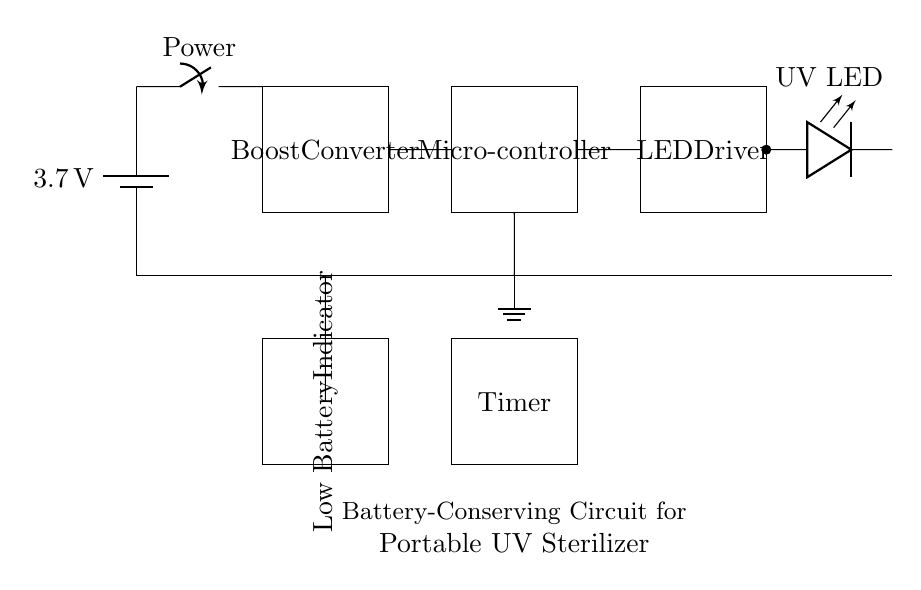What is the voltage rating of the battery? The voltage rating of the battery is indicated on the battery symbol, which shows a value of 3.7 volts.
Answer: 3.7 volts What component is responsible for boosting the voltage? The circuit contains a component labeled as the Boost Converter, which is specifically designed to increase the voltage from the battery to a higher level required for the other components.
Answer: Boost Converter What is the purpose of the timer in this circuit? The Timer's role in this circuit is to control the duration of the UV light exposure, thereby enhancing the sterilization process for the medical instruments.
Answer: Control duration What does the low battery indicator signify? The Low Battery Indicator serves as a warning to signal when the battery charge is too low for effective operation, which is crucial for maintaining the sterilizer's functionality.
Answer: Battery charge warning What type of LED is used in this circuit? The circuit employs a UV LED, specified in the diagram, which emits ultraviolet light necessary for the sterilization of medical instruments.
Answer: UV LED How does the microcontroller contribute to battery conservation? The Microcontroller regulates the operation of the circuit, including controlling the LED and Timer. By managing the timing and power supply efficiently, it minimizes energy consumption, thereby conserving battery life.
Answer: Regulates power consumption What is the purpose of the switch in this circuit? The switch is used to turn the circuit on or off, allowing the user to control when to activate the sterilization process, which helps in conserving battery power when not in use.
Answer: On/Off control 